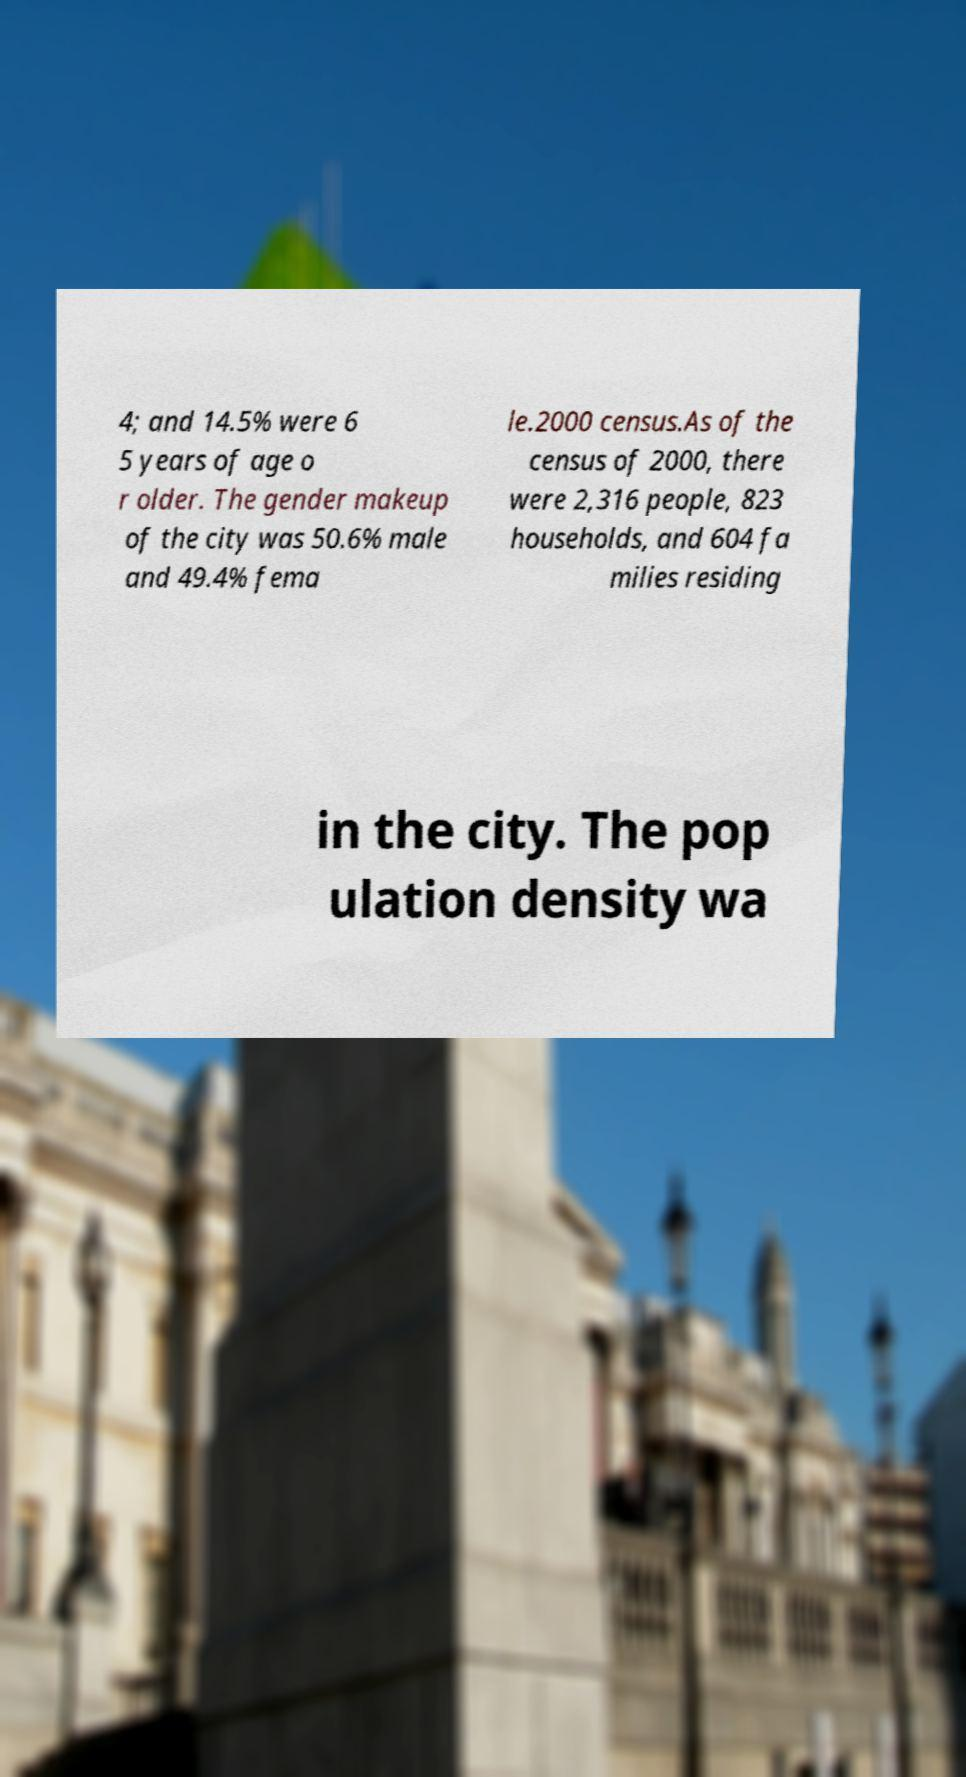Please identify and transcribe the text found in this image. 4; and 14.5% were 6 5 years of age o r older. The gender makeup of the city was 50.6% male and 49.4% fema le.2000 census.As of the census of 2000, there were 2,316 people, 823 households, and 604 fa milies residing in the city. The pop ulation density wa 